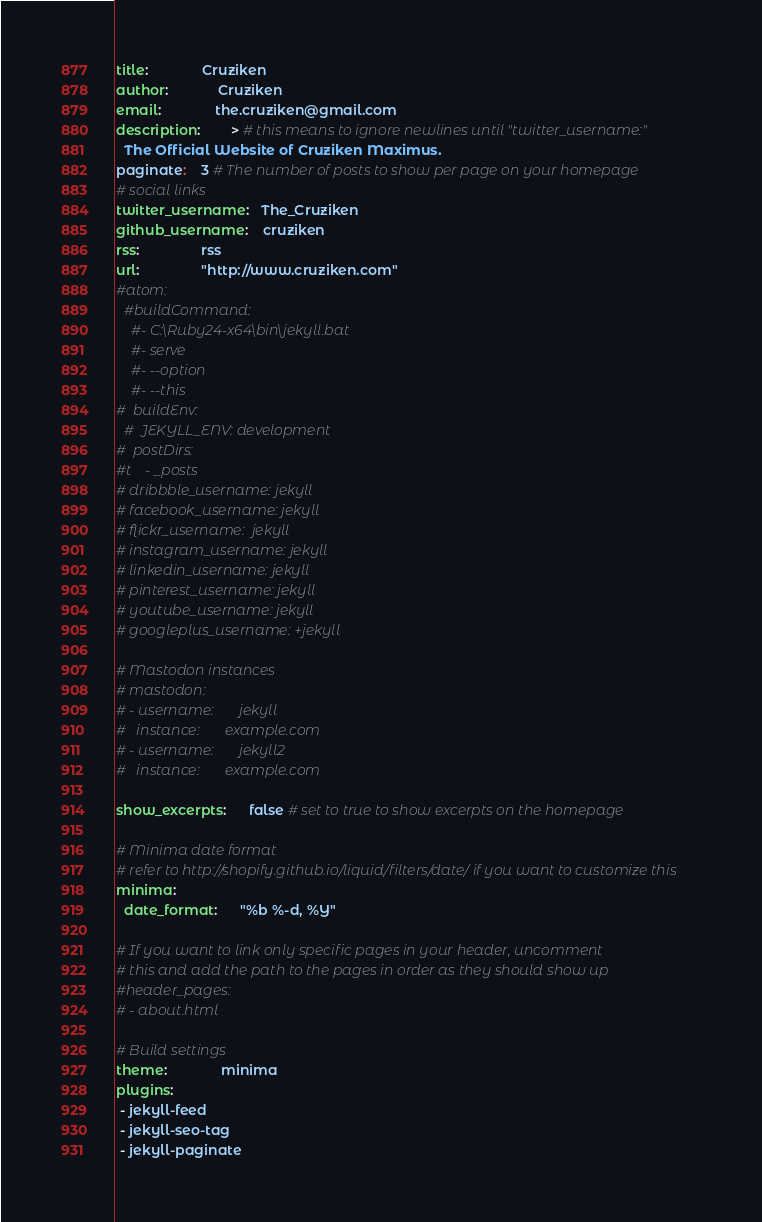Convert code to text. <code><loc_0><loc_0><loc_500><loc_500><_YAML_>title:              Cruziken
author:             Cruziken
email:              the.cruziken@gmail.com
description:        > # this means to ignore newlines until "twitter_username:"
  The Official Website of Cruziken Maximus.
paginate:	3 # The number of posts to show per page on your homepage
# social links
twitter_username:   The_Cruziken
github_username:    cruziken
rss:                rss
url:                "http://www.cruziken.com"
#atom:
  #buildCommand:
    #- C:\Ruby24-x64\bin\jekyll.bat
    #- serve
    #- --option
    #- --this
#  buildEnv:
  #  JEKYLL_ENV: development
#  postDirs:
#t    - _posts
# dribbble_username: jekyll
# facebook_username: jekyll
# flickr_username:  jekyll
# instagram_username: jekyll
# linkedin_username: jekyll
# pinterest_username: jekyll
# youtube_username: jekyll
# googleplus_username: +jekyll

# Mastodon instances
# mastodon:
# - username:       jekyll
#   instance:       example.com
# - username:       jekyll2
#   instance:       example.com

show_excerpts:      false # set to true to show excerpts on the homepage

# Minima date format
# refer to http://shopify.github.io/liquid/filters/date/ if you want to customize this
minima:
  date_format:      "%b %-d, %Y"

# If you want to link only specific pages in your header, uncomment
# this and add the path to the pages in order as they should show up
#header_pages:
# - about.html

# Build settings
theme:              minima
plugins:
 - jekyll-feed
 - jekyll-seo-tag
 - jekyll-paginate
</code> 